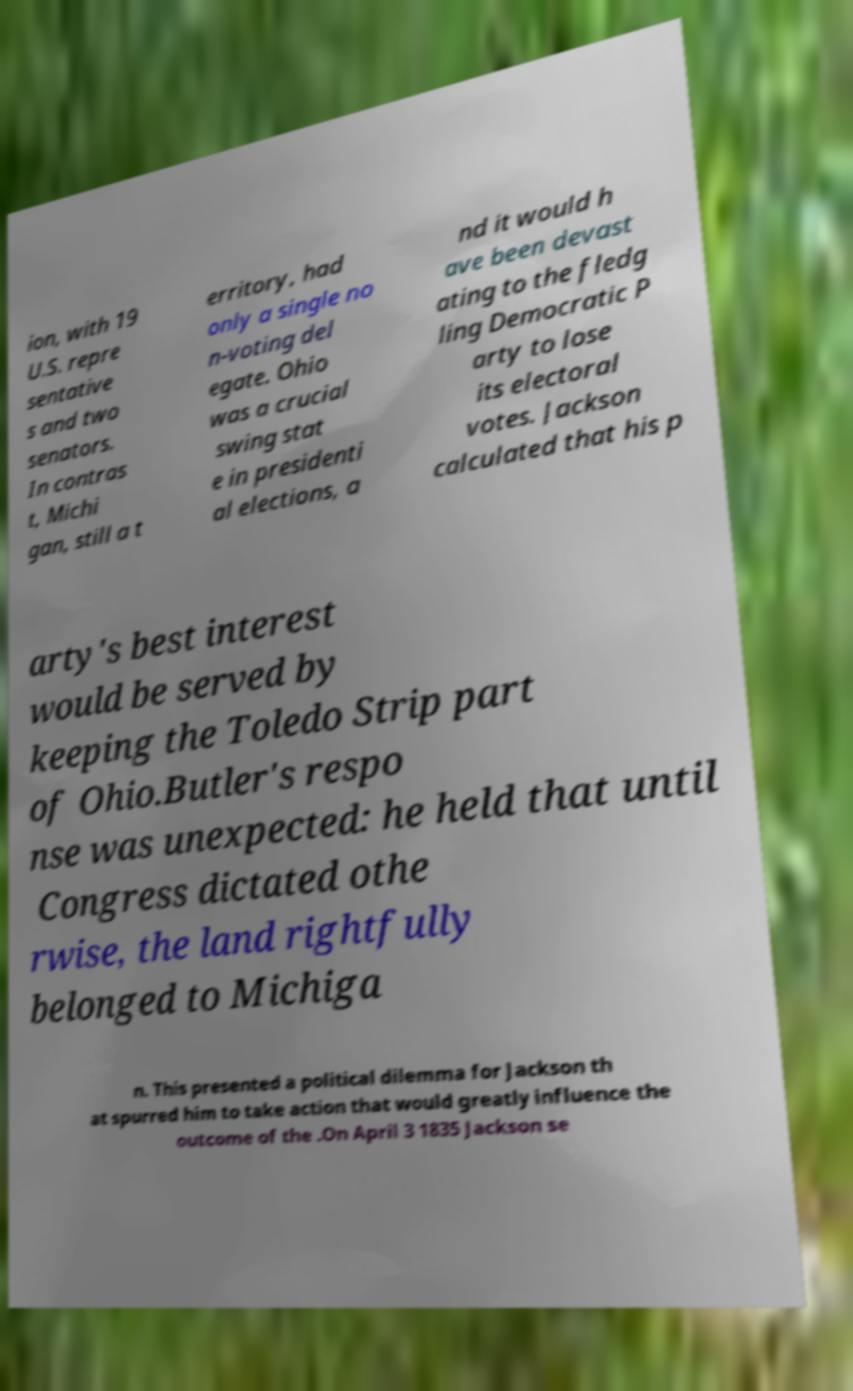What messages or text are displayed in this image? I need them in a readable, typed format. ion, with 19 U.S. repre sentative s and two senators. In contras t, Michi gan, still a t erritory, had only a single no n-voting del egate. Ohio was a crucial swing stat e in presidenti al elections, a nd it would h ave been devast ating to the fledg ling Democratic P arty to lose its electoral votes. Jackson calculated that his p arty's best interest would be served by keeping the Toledo Strip part of Ohio.Butler's respo nse was unexpected: he held that until Congress dictated othe rwise, the land rightfully belonged to Michiga n. This presented a political dilemma for Jackson th at spurred him to take action that would greatly influence the outcome of the .On April 3 1835 Jackson se 